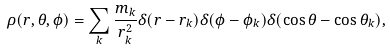<formula> <loc_0><loc_0><loc_500><loc_500>\rho ( r , \theta , \phi ) = \sum _ { k } \frac { m _ { k } } { r _ { k } ^ { 2 } } \delta ( r - r _ { k } ) \delta ( \phi - \phi _ { k } ) \delta ( \cos \theta - \cos \theta _ { k } ) ,</formula> 